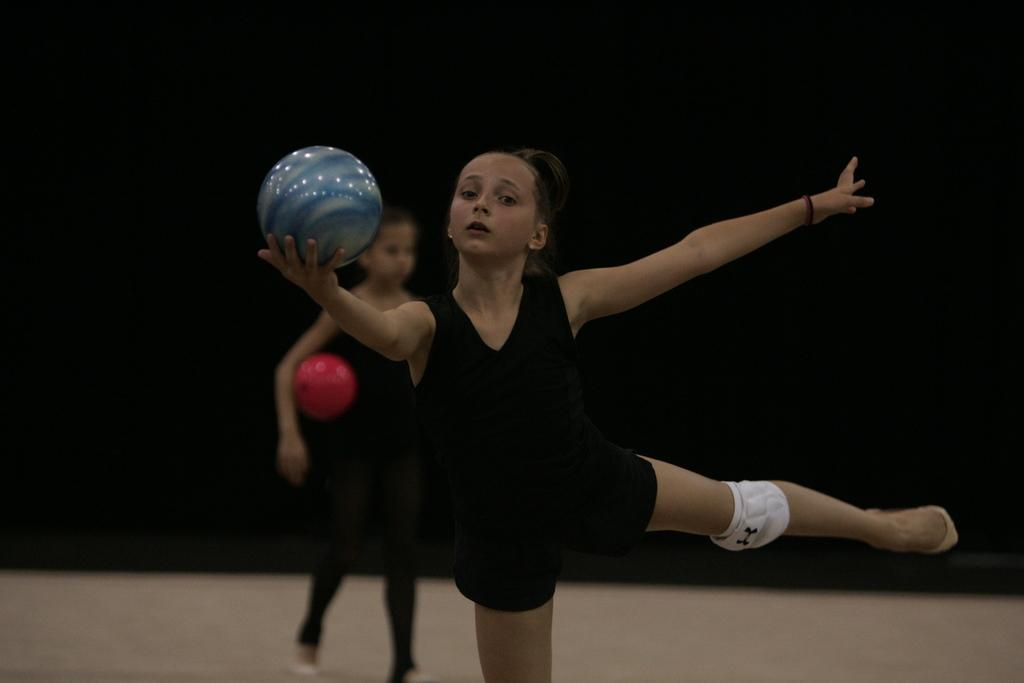How many people are in the image? There are two girls in the image. What are the girls doing in the image? The girls are playing with a ball. Where is the ball located in the image? The ball is on the ground. Can you show me the receipt for the ball in the image? There is no receipt present in the image, as it is focused on the girls playing with the ball. 